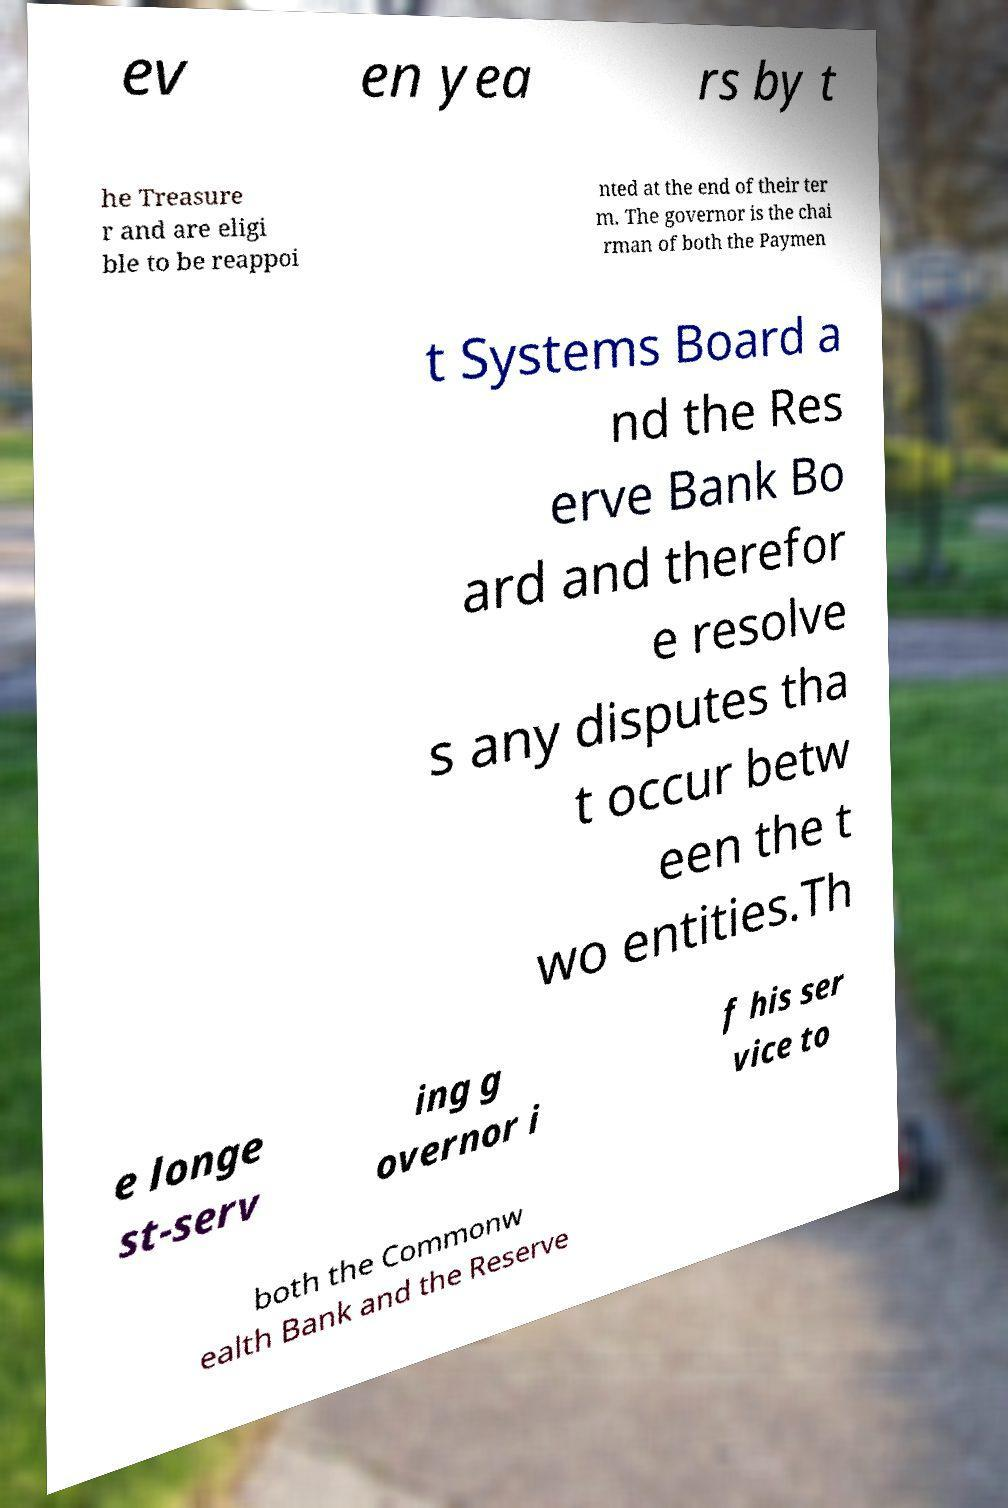For documentation purposes, I need the text within this image transcribed. Could you provide that? ev en yea rs by t he Treasure r and are eligi ble to be reappoi nted at the end of their ter m. The governor is the chai rman of both the Paymen t Systems Board a nd the Res erve Bank Bo ard and therefor e resolve s any disputes tha t occur betw een the t wo entities.Th e longe st-serv ing g overnor i f his ser vice to both the Commonw ealth Bank and the Reserve 